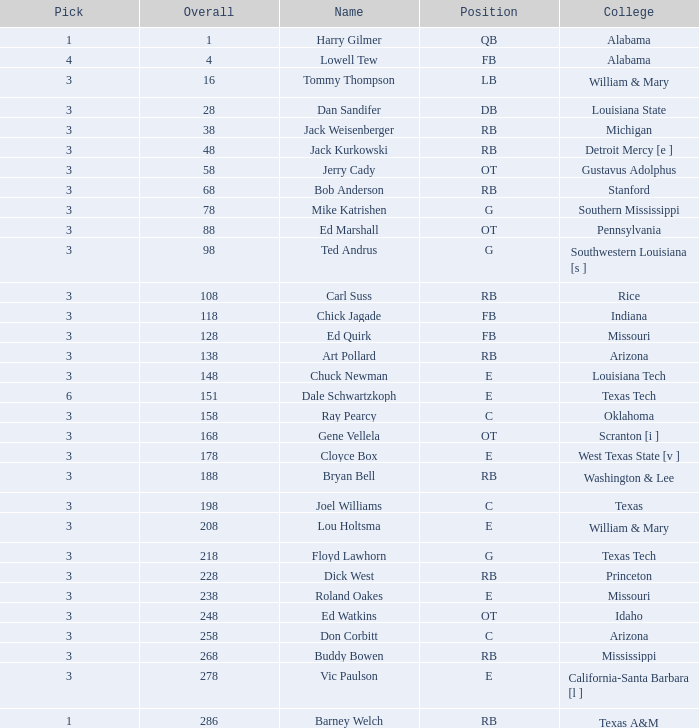What is the total sum related to the name bob anderson? 1.0. 